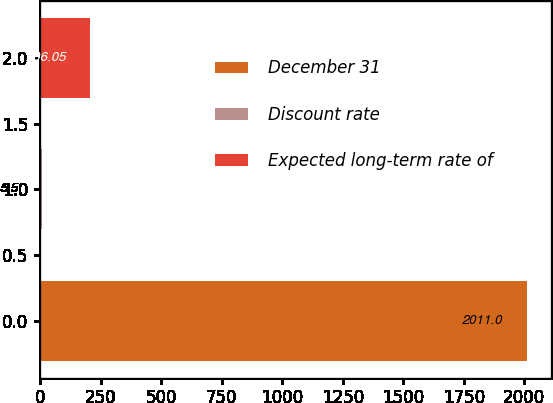<chart> <loc_0><loc_0><loc_500><loc_500><bar_chart><fcel>December 31<fcel>Discount rate<fcel>Expected long-term rate of<nl><fcel>2011<fcel>5.5<fcel>206.05<nl></chart> 